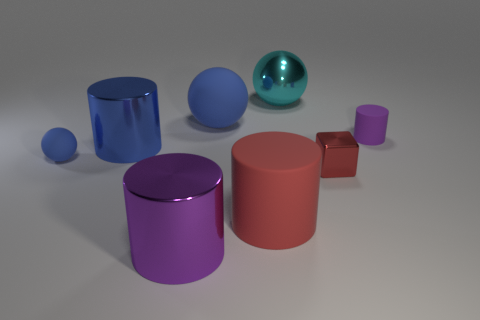How many large things are shiny cylinders or red rubber cylinders?
Offer a very short reply. 3. The large purple object that is made of the same material as the large cyan sphere is what shape?
Offer a very short reply. Cylinder. Are there fewer metallic objects that are to the right of the tiny cylinder than large objects?
Offer a very short reply. Yes. Does the large blue rubber object have the same shape as the tiny purple object?
Make the answer very short. No. What number of metallic things are large red cylinders or cubes?
Keep it short and to the point. 1. Is there a blue rubber thing of the same size as the blue metal thing?
Keep it short and to the point. Yes. What is the shape of the large thing that is the same color as the tiny shiny block?
Make the answer very short. Cylinder. What number of other purple objects have the same size as the purple rubber thing?
Offer a terse response. 0. There is a metal cylinder behind the big rubber cylinder; is its size the same as the rubber sphere that is to the right of the small blue sphere?
Make the answer very short. Yes. How many things are blue cylinders or objects that are on the left side of the large cyan ball?
Your answer should be compact. 5. 